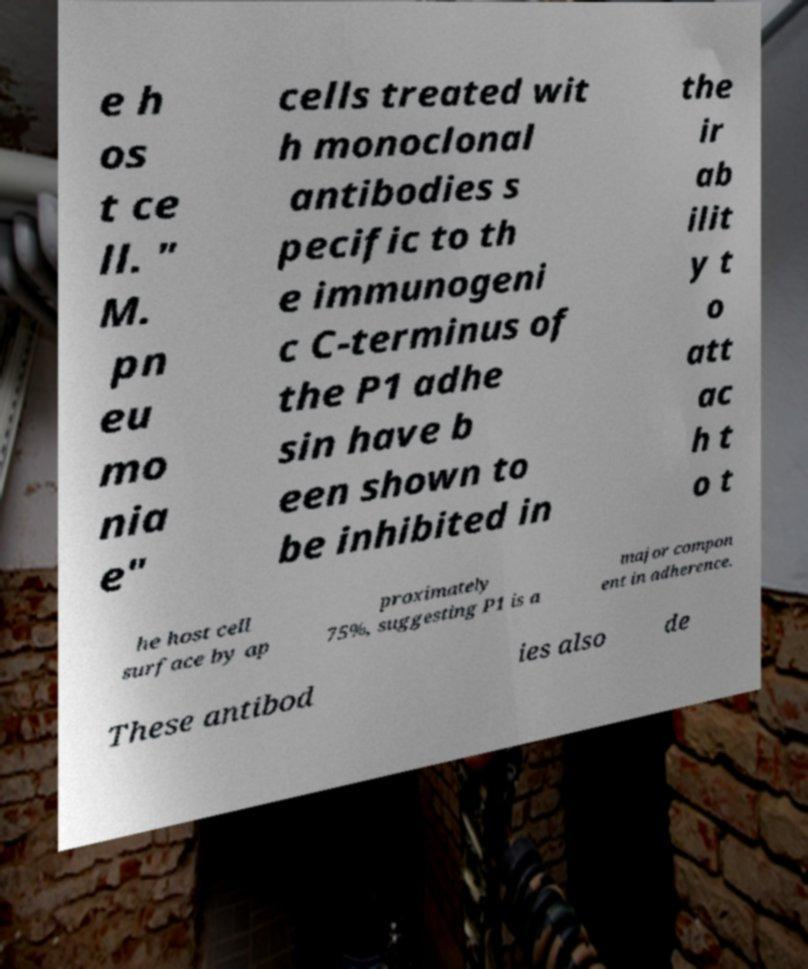Could you assist in decoding the text presented in this image and type it out clearly? e h os t ce ll. " M. pn eu mo nia e" cells treated wit h monoclonal antibodies s pecific to th e immunogeni c C-terminus of the P1 adhe sin have b een shown to be inhibited in the ir ab ilit y t o att ac h t o t he host cell surface by ap proximately 75%, suggesting P1 is a major compon ent in adherence. These antibod ies also de 